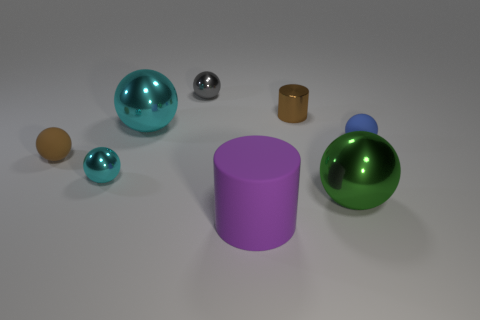Add 2 big metallic objects. How many objects exist? 10 Subtract 3 balls. How many balls are left? 3 Subtract all blue spheres. How many spheres are left? 5 Subtract all cylinders. How many objects are left? 6 Subtract all small brown balls. Subtract all small gray objects. How many objects are left? 6 Add 2 small metal balls. How many small metal balls are left? 4 Add 4 small green matte balls. How many small green matte balls exist? 4 Subtract all brown balls. How many balls are left? 5 Subtract 0 purple cubes. How many objects are left? 8 Subtract all red spheres. Subtract all yellow blocks. How many spheres are left? 6 